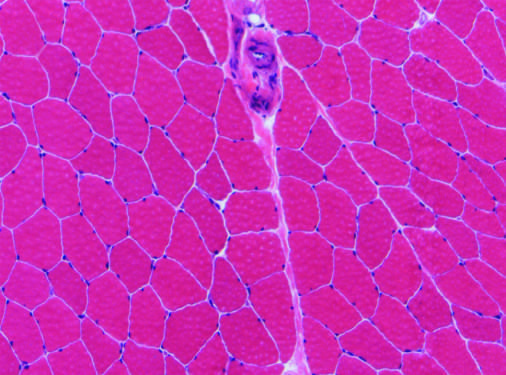s a perimysial interfascicular septum containing a blood vessel present?
Answer the question using a single word or phrase. Yes 